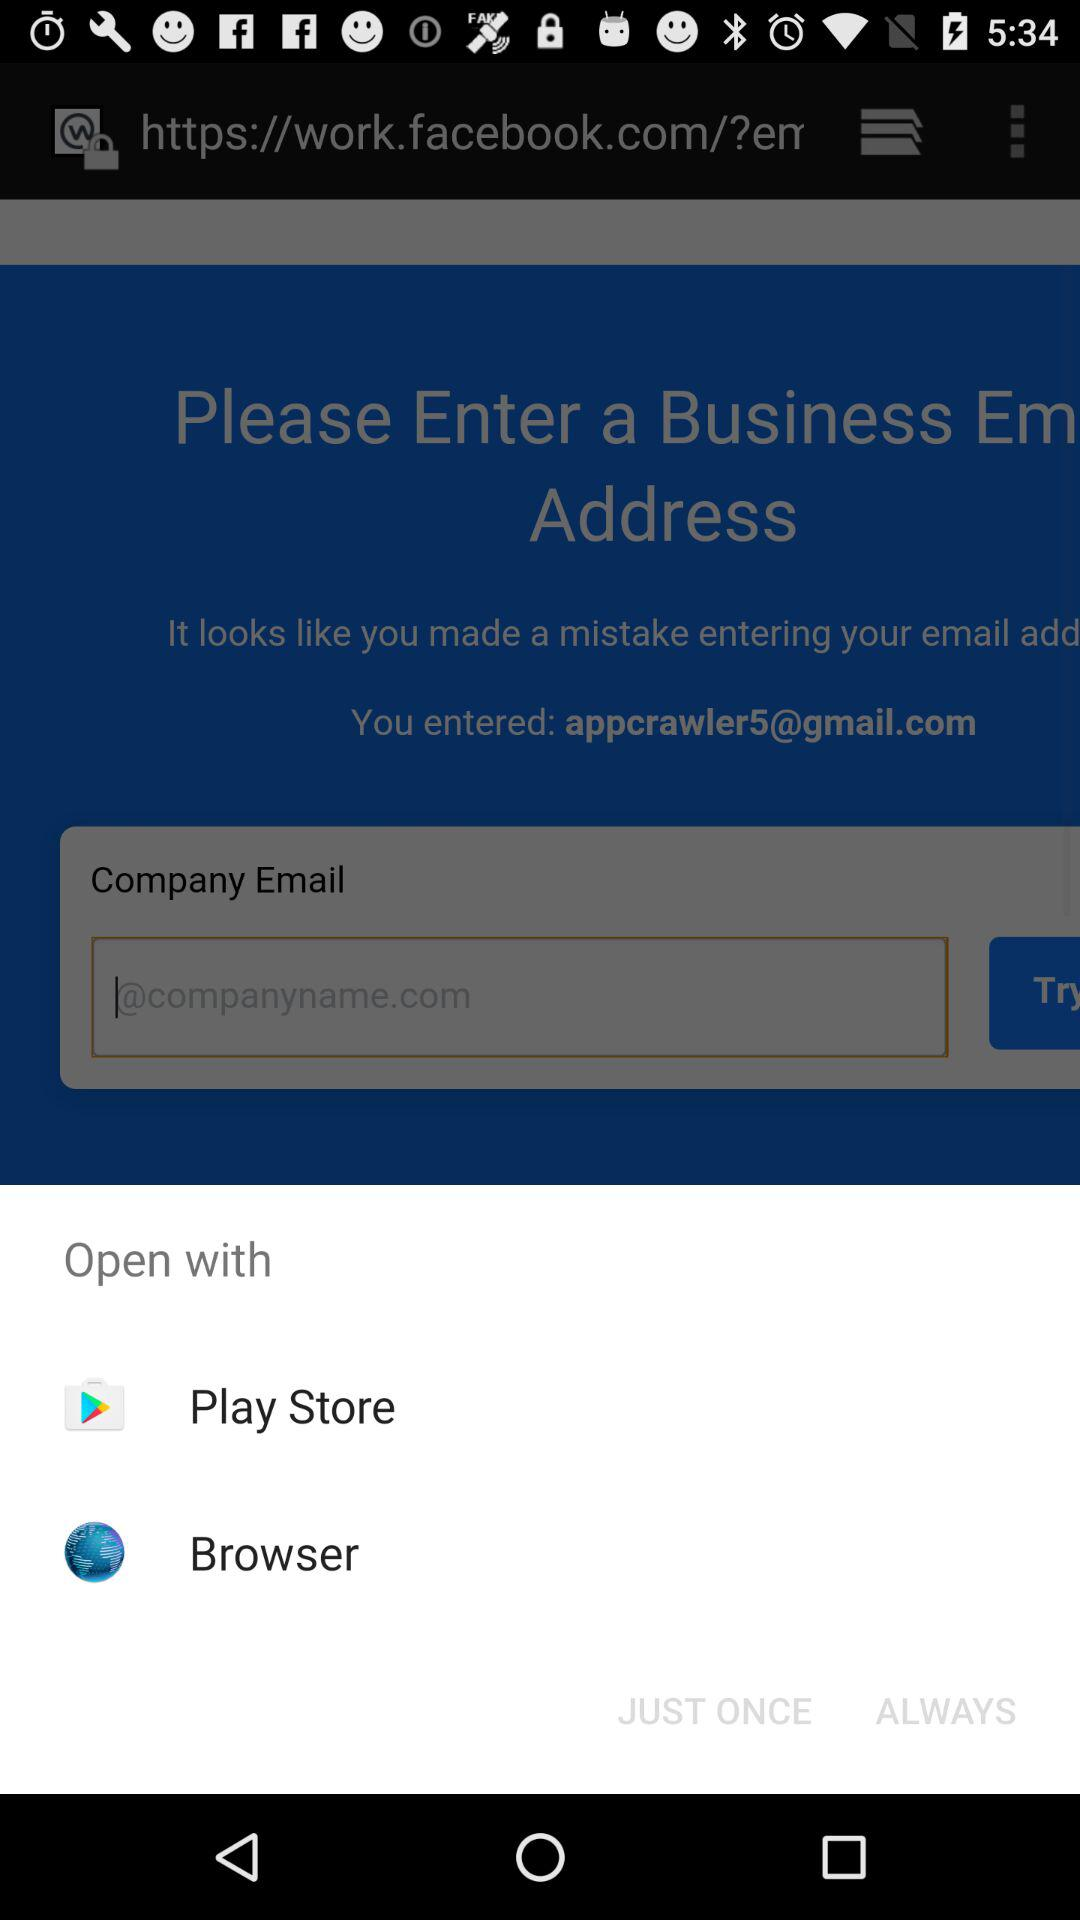What is an email address? The email address is appcrawler5@gmail.com. 